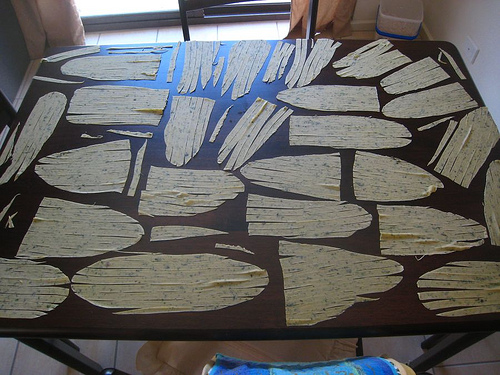<image>
Can you confirm if the table is on the floor? Yes. Looking at the image, I can see the table is positioned on top of the floor, with the floor providing support. 